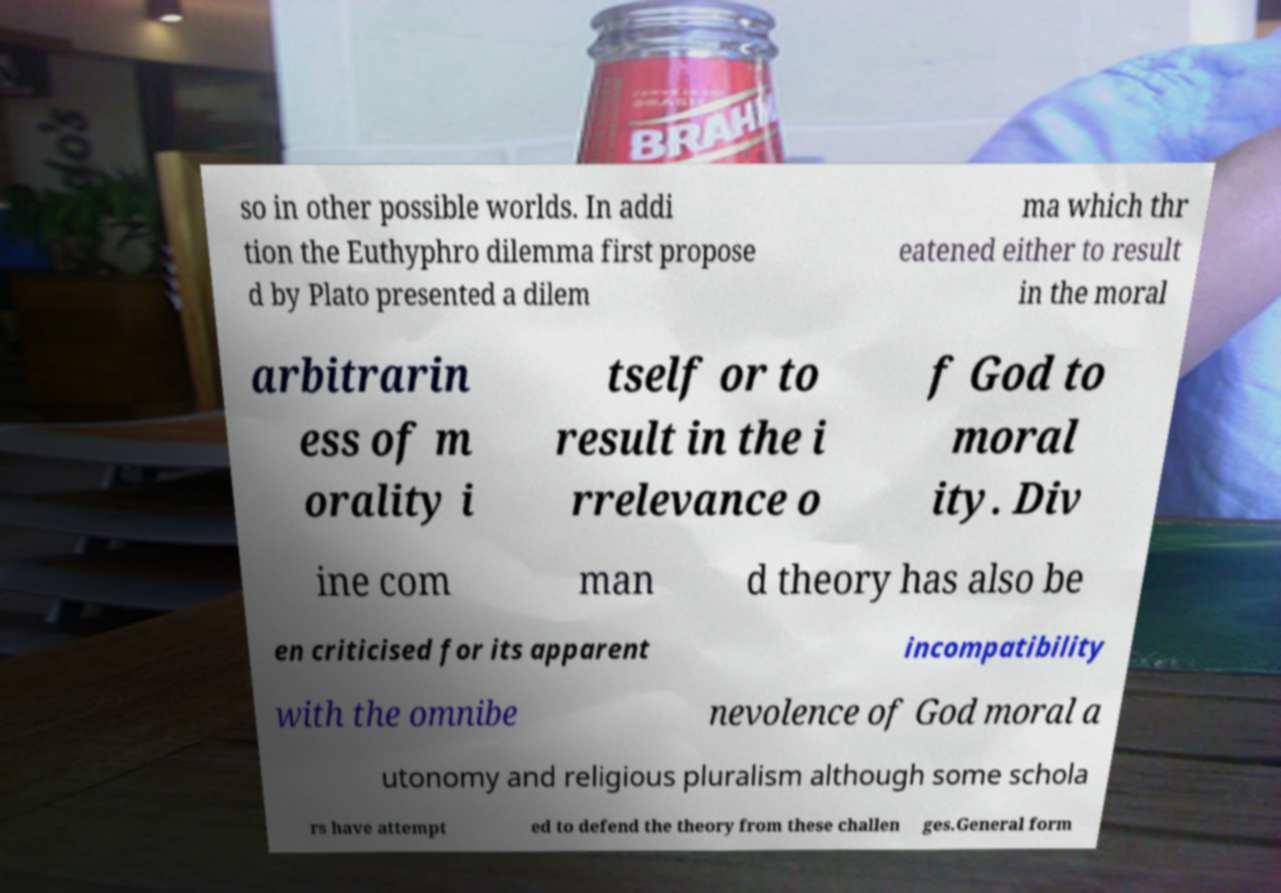Could you extract and type out the text from this image? so in other possible worlds. In addi tion the Euthyphro dilemma first propose d by Plato presented a dilem ma which thr eatened either to result in the moral arbitrarin ess of m orality i tself or to result in the i rrelevance o f God to moral ity. Div ine com man d theory has also be en criticised for its apparent incompatibility with the omnibe nevolence of God moral a utonomy and religious pluralism although some schola rs have attempt ed to defend the theory from these challen ges.General form 